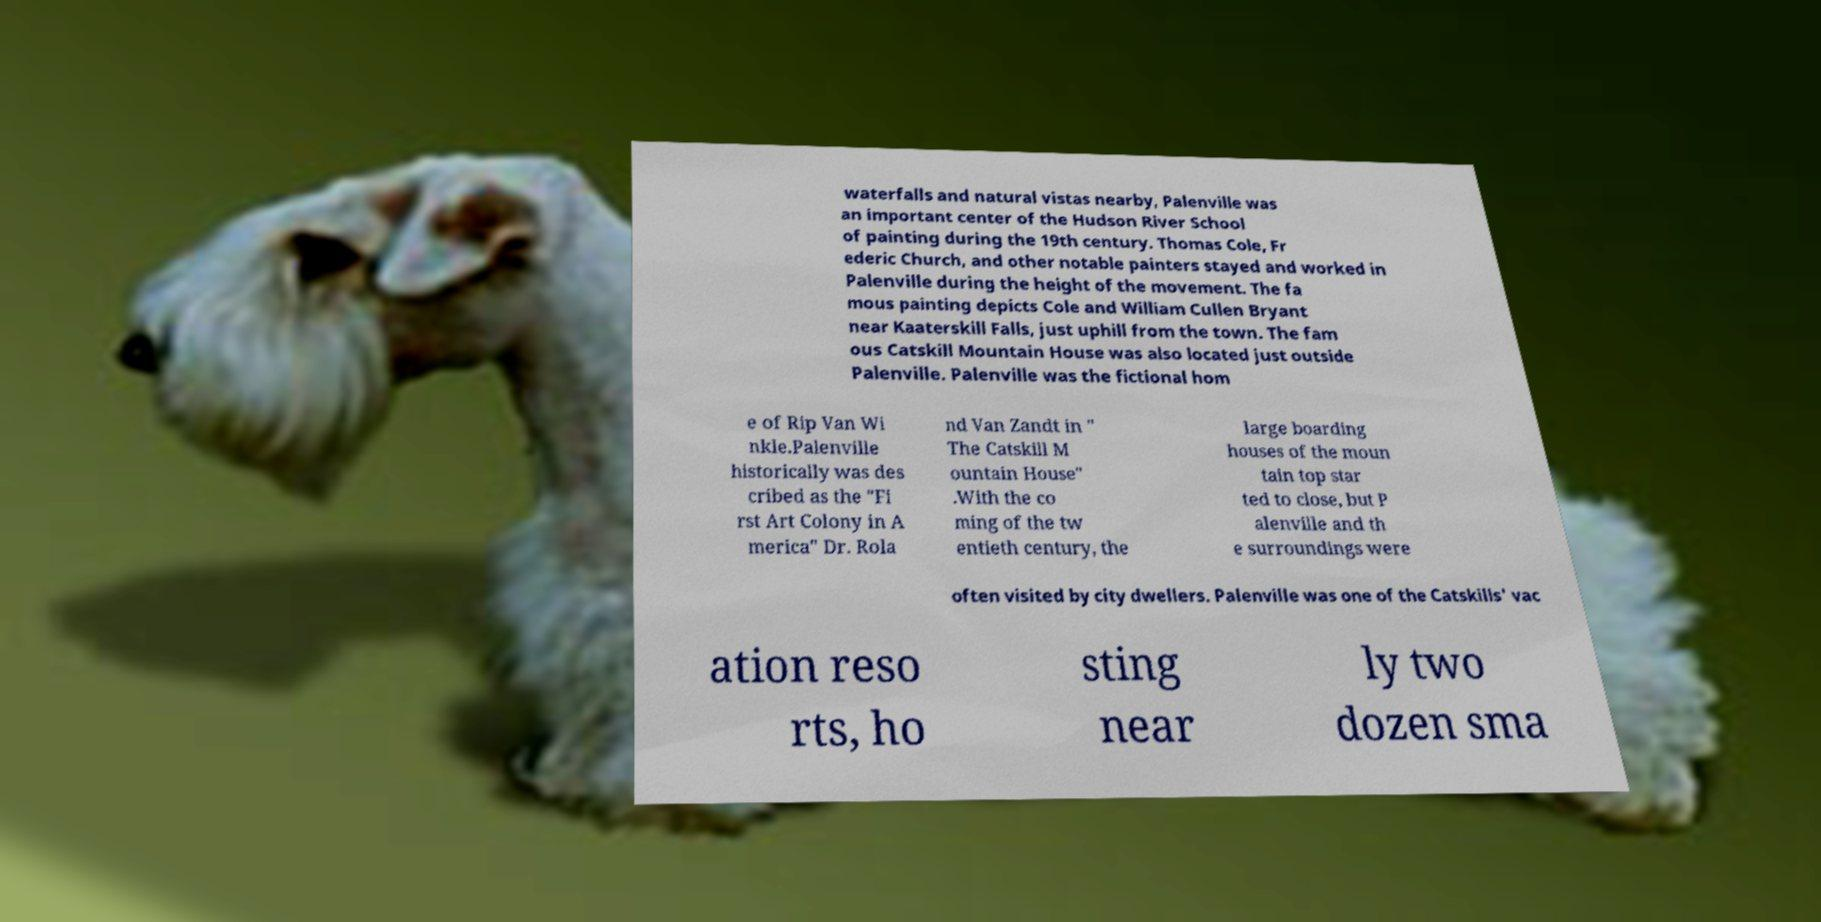Could you assist in decoding the text presented in this image and type it out clearly? waterfalls and natural vistas nearby, Palenville was an important center of the Hudson River School of painting during the 19th century. Thomas Cole, Fr ederic Church, and other notable painters stayed and worked in Palenville during the height of the movement. The fa mous painting depicts Cole and William Cullen Bryant near Kaaterskill Falls, just uphill from the town. The fam ous Catskill Mountain House was also located just outside Palenville. Palenville was the fictional hom e of Rip Van Wi nkle.Palenville historically was des cribed as the "Fi rst Art Colony in A merica" Dr. Rola nd Van Zandt in " The Catskill M ountain House" .With the co ming of the tw entieth century, the large boarding houses of the moun tain top star ted to close, but P alenville and th e surroundings were often visited by city dwellers. Palenville was one of the Catskills' vac ation reso rts, ho sting near ly two dozen sma 